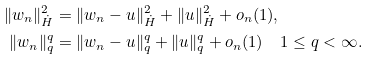Convert formula to latex. <formula><loc_0><loc_0><loc_500><loc_500>\| w _ { n } \| _ { \dot { H } } ^ { 2 } & = \| w _ { n } - u \| _ { \dot { H } } ^ { 2 } + \| u \| _ { \dot { H } } ^ { 2 } + o _ { n } ( 1 ) , \\ \| w _ { n } \| _ { q } ^ { q } & = \| w _ { n } - u \| _ { q } ^ { q } + \| u \| _ { q } ^ { q } + o _ { n } ( 1 ) \quad 1 \leq q < \infty .</formula> 